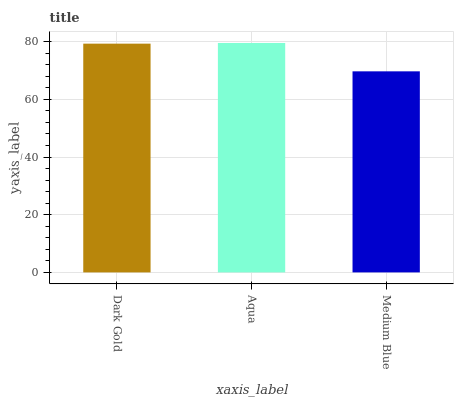Is Medium Blue the minimum?
Answer yes or no. Yes. Is Aqua the maximum?
Answer yes or no. Yes. Is Aqua the minimum?
Answer yes or no. No. Is Medium Blue the maximum?
Answer yes or no. No. Is Aqua greater than Medium Blue?
Answer yes or no. Yes. Is Medium Blue less than Aqua?
Answer yes or no. Yes. Is Medium Blue greater than Aqua?
Answer yes or no. No. Is Aqua less than Medium Blue?
Answer yes or no. No. Is Dark Gold the high median?
Answer yes or no. Yes. Is Dark Gold the low median?
Answer yes or no. Yes. Is Medium Blue the high median?
Answer yes or no. No. Is Aqua the low median?
Answer yes or no. No. 